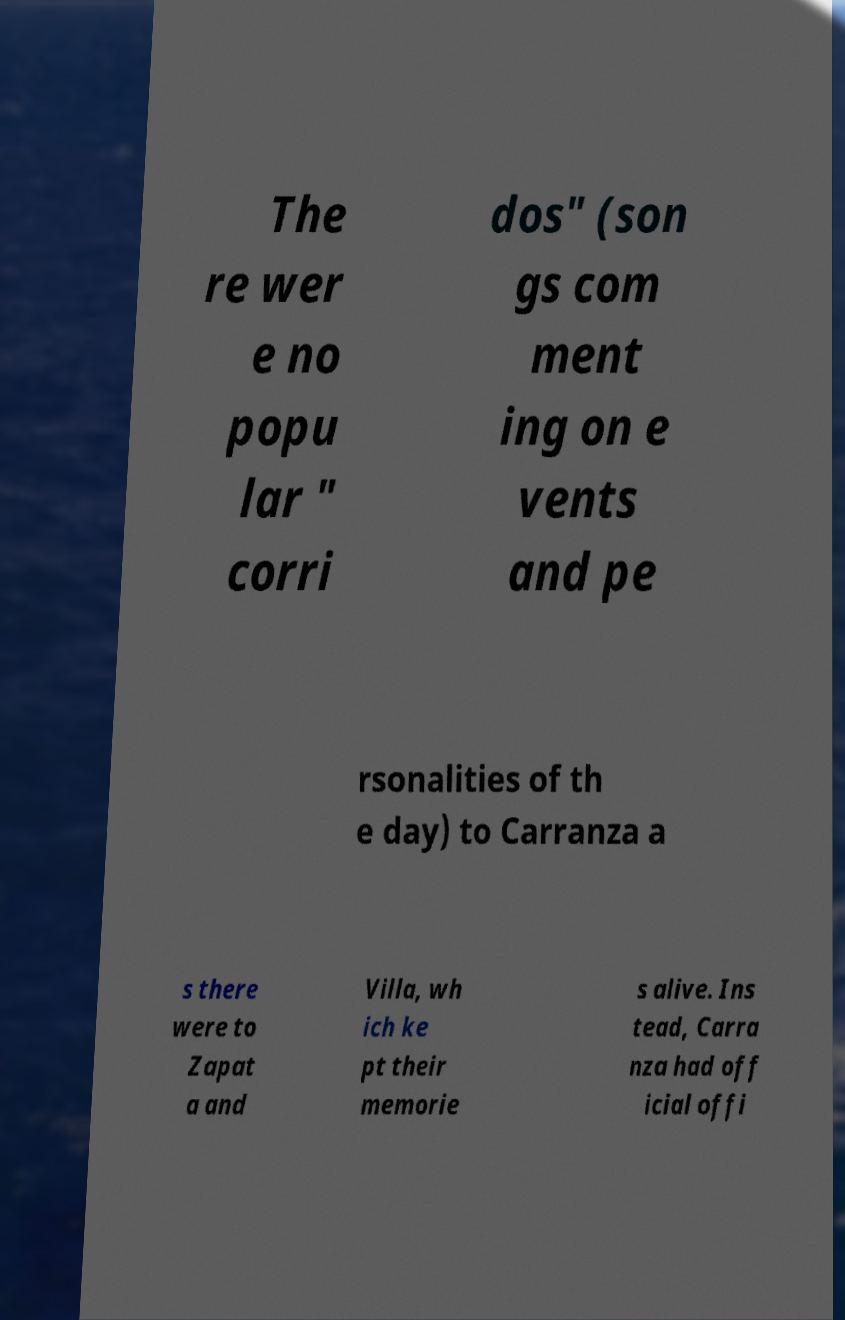Can you accurately transcribe the text from the provided image for me? The re wer e no popu lar " corri dos" (son gs com ment ing on e vents and pe rsonalities of th e day) to Carranza a s there were to Zapat a and Villa, wh ich ke pt their memorie s alive. Ins tead, Carra nza had off icial offi 